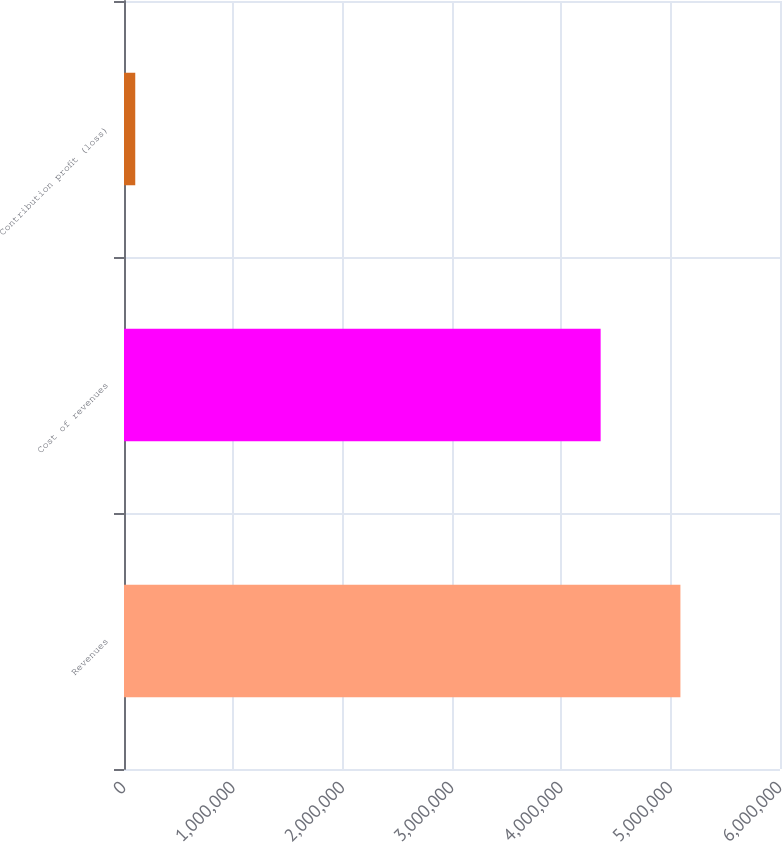Convert chart to OTSL. <chart><loc_0><loc_0><loc_500><loc_500><bar_chart><fcel>Revenues<fcel>Cost of revenues<fcel>Contribution profit (loss)<nl><fcel>5.08919e+06<fcel>4.35962e+06<fcel>102960<nl></chart> 